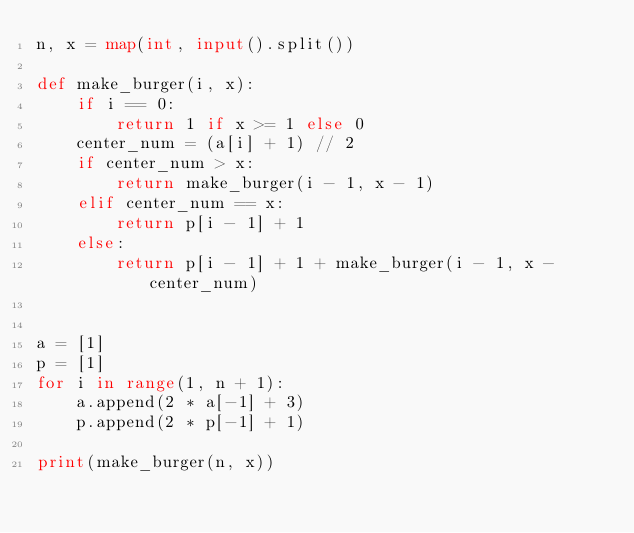<code> <loc_0><loc_0><loc_500><loc_500><_Python_>n, x = map(int, input().split())

def make_burger(i, x):
    if i == 0:
        return 1 if x >= 1 else 0
    center_num = (a[i] + 1) // 2
    if center_num > x:
        return make_burger(i - 1, x - 1)
    elif center_num == x:
        return p[i - 1] + 1
    else:
        return p[i - 1] + 1 + make_burger(i - 1, x - center_num)


a = [1]
p = [1]
for i in range(1, n + 1):
    a.append(2 * a[-1] + 3)
    p.append(2 * p[-1] + 1)

print(make_burger(n, x))</code> 